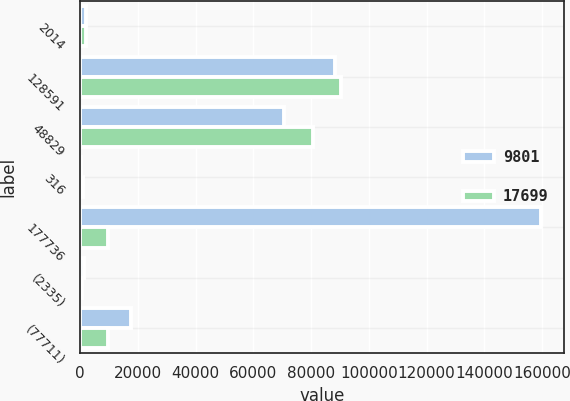Convert chart to OTSL. <chart><loc_0><loc_0><loc_500><loc_500><stacked_bar_chart><ecel><fcel>2014<fcel>128591<fcel>48829<fcel>316<fcel>177736<fcel>(2335)<fcel>(77711)<nl><fcel>9801<fcel>2013<fcel>88431<fcel>70656<fcel>448<fcel>159535<fcel>1499<fcel>17699<nl><fcel>17699<fcel>2012<fcel>90303<fcel>80825<fcel>970<fcel>9801<fcel>698<fcel>9801<nl></chart> 